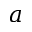<formula> <loc_0><loc_0><loc_500><loc_500>a</formula> 